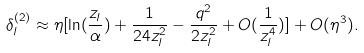<formula> <loc_0><loc_0><loc_500><loc_500>\delta _ { l } ^ { ( 2 ) } \approx \eta [ \ln ( \frac { z _ { l } } \alpha ) + \frac { 1 } { 2 4 z _ { l } ^ { 2 } } - \frac { q ^ { 2 } } { 2 z _ { l } ^ { 2 } } + O ( \frac { 1 } { z _ { l } ^ { 4 } } ) ] + O ( \eta ^ { 3 } ) .</formula> 